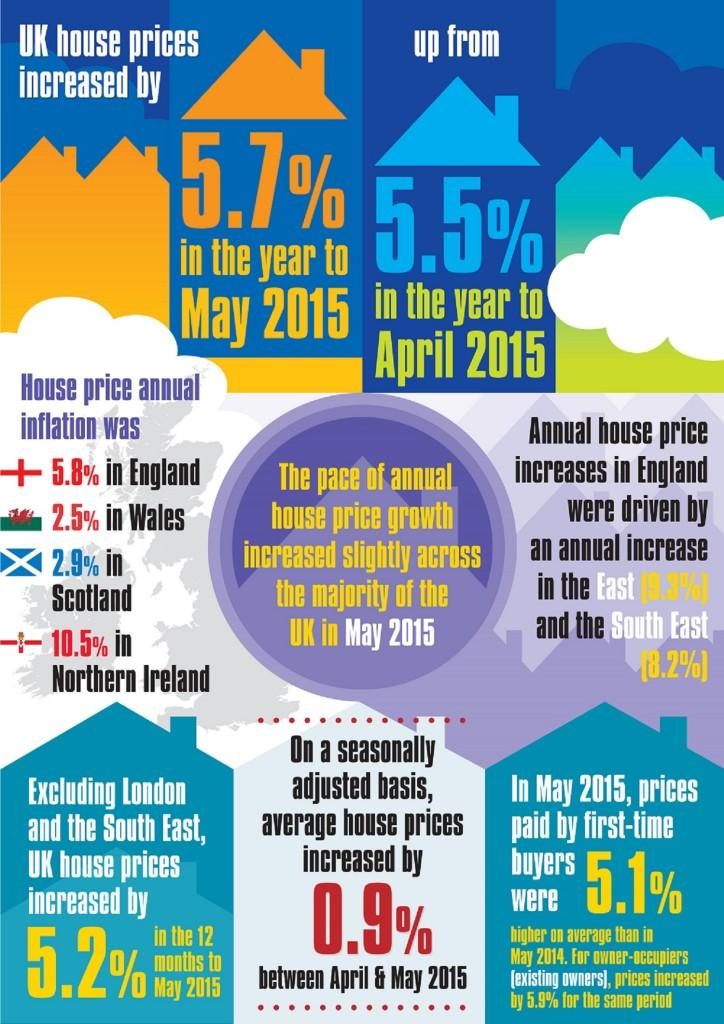Indicate a few pertinent items in this graphic. According to the latest data, the annual inflation rate of house prices was lowest in Wales, with no specific country mentioned. There are only two months mentioned in this infographic. There are 4 countries depicted in this infographic. The annual inflation rate for house prices was highest in Northern Ireland. 